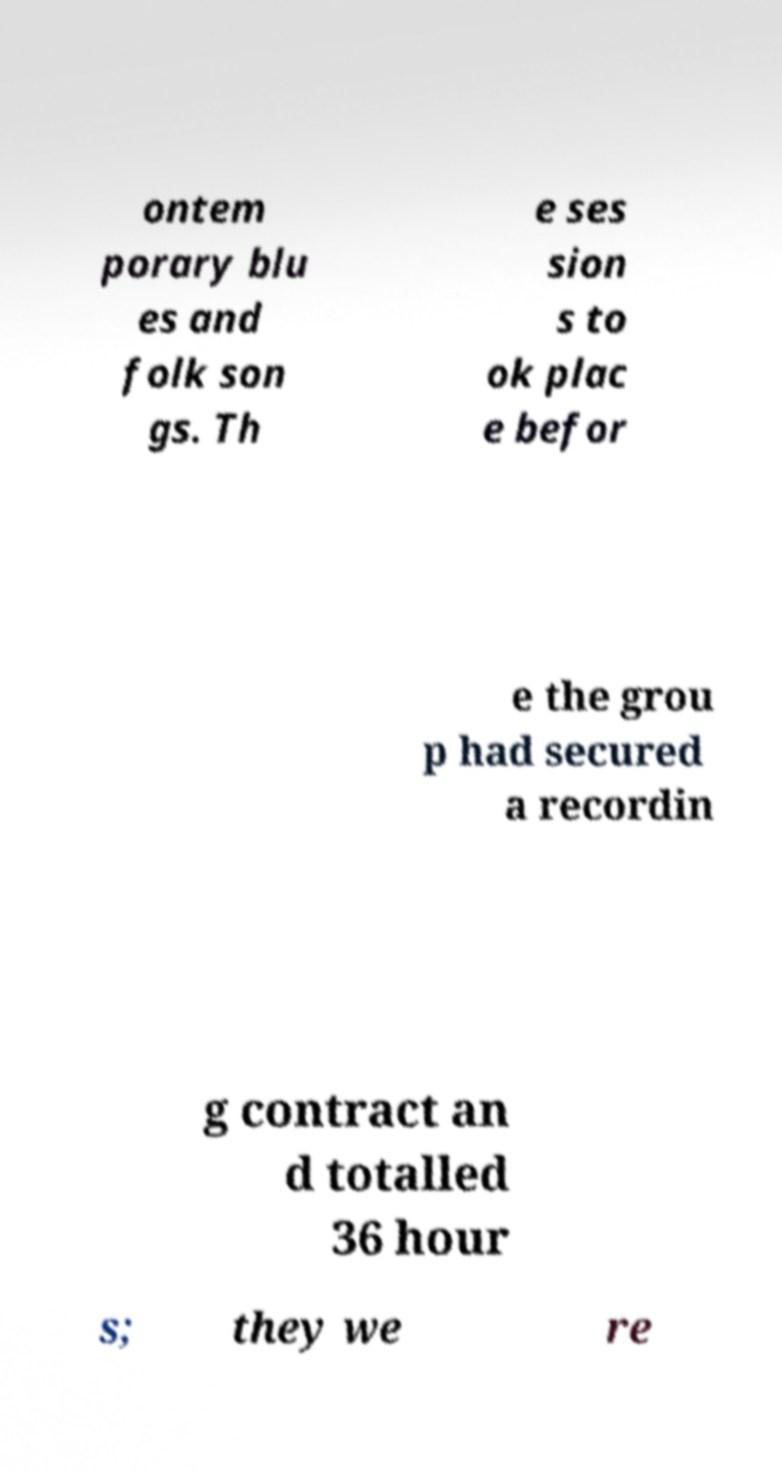For documentation purposes, I need the text within this image transcribed. Could you provide that? ontem porary blu es and folk son gs. Th e ses sion s to ok plac e befor e the grou p had secured a recordin g contract an d totalled 36 hour s; they we re 